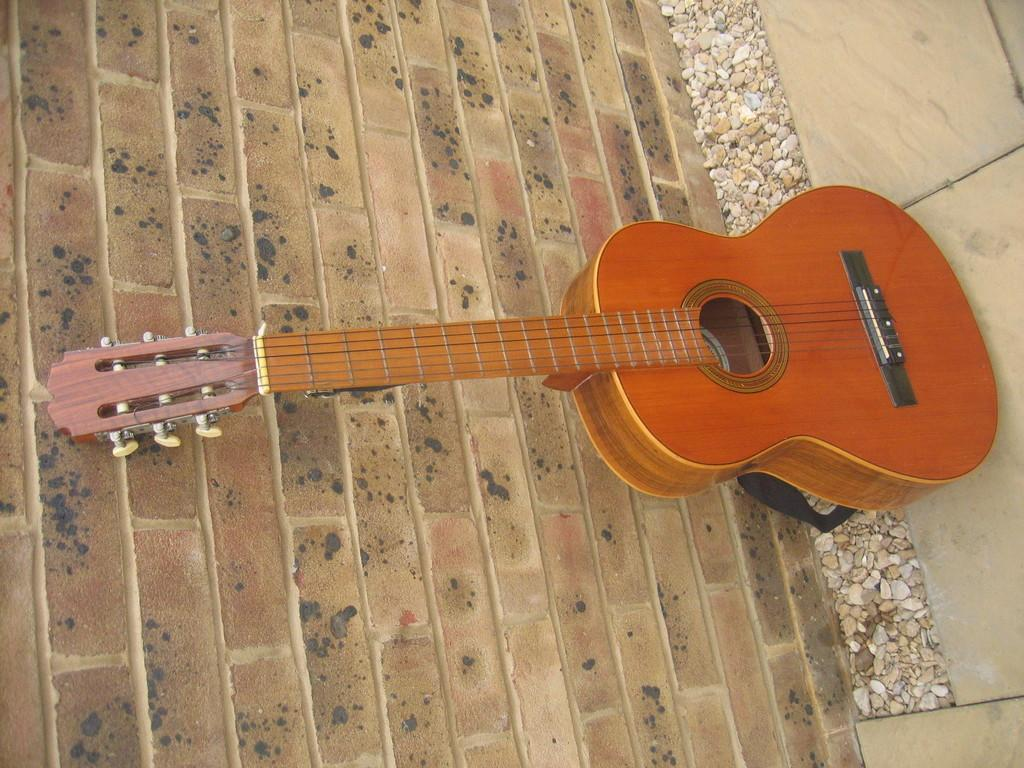What musical instrument is present in the image? There is a guitar in the image. What feature of the guitar is mentioned in the facts? The guitar has strings. What type of wall can be seen on the left side of the image? There is a brick wall on the left side of the image. What type of flooring is visible on the right side of the image? There are tiles on the right side of the image. What type of natural material is visible in the image? There are stones visible in the image. What type of knife is being used to cut the pig on the table in the image? There is no knife, pig, or table present in the image. 